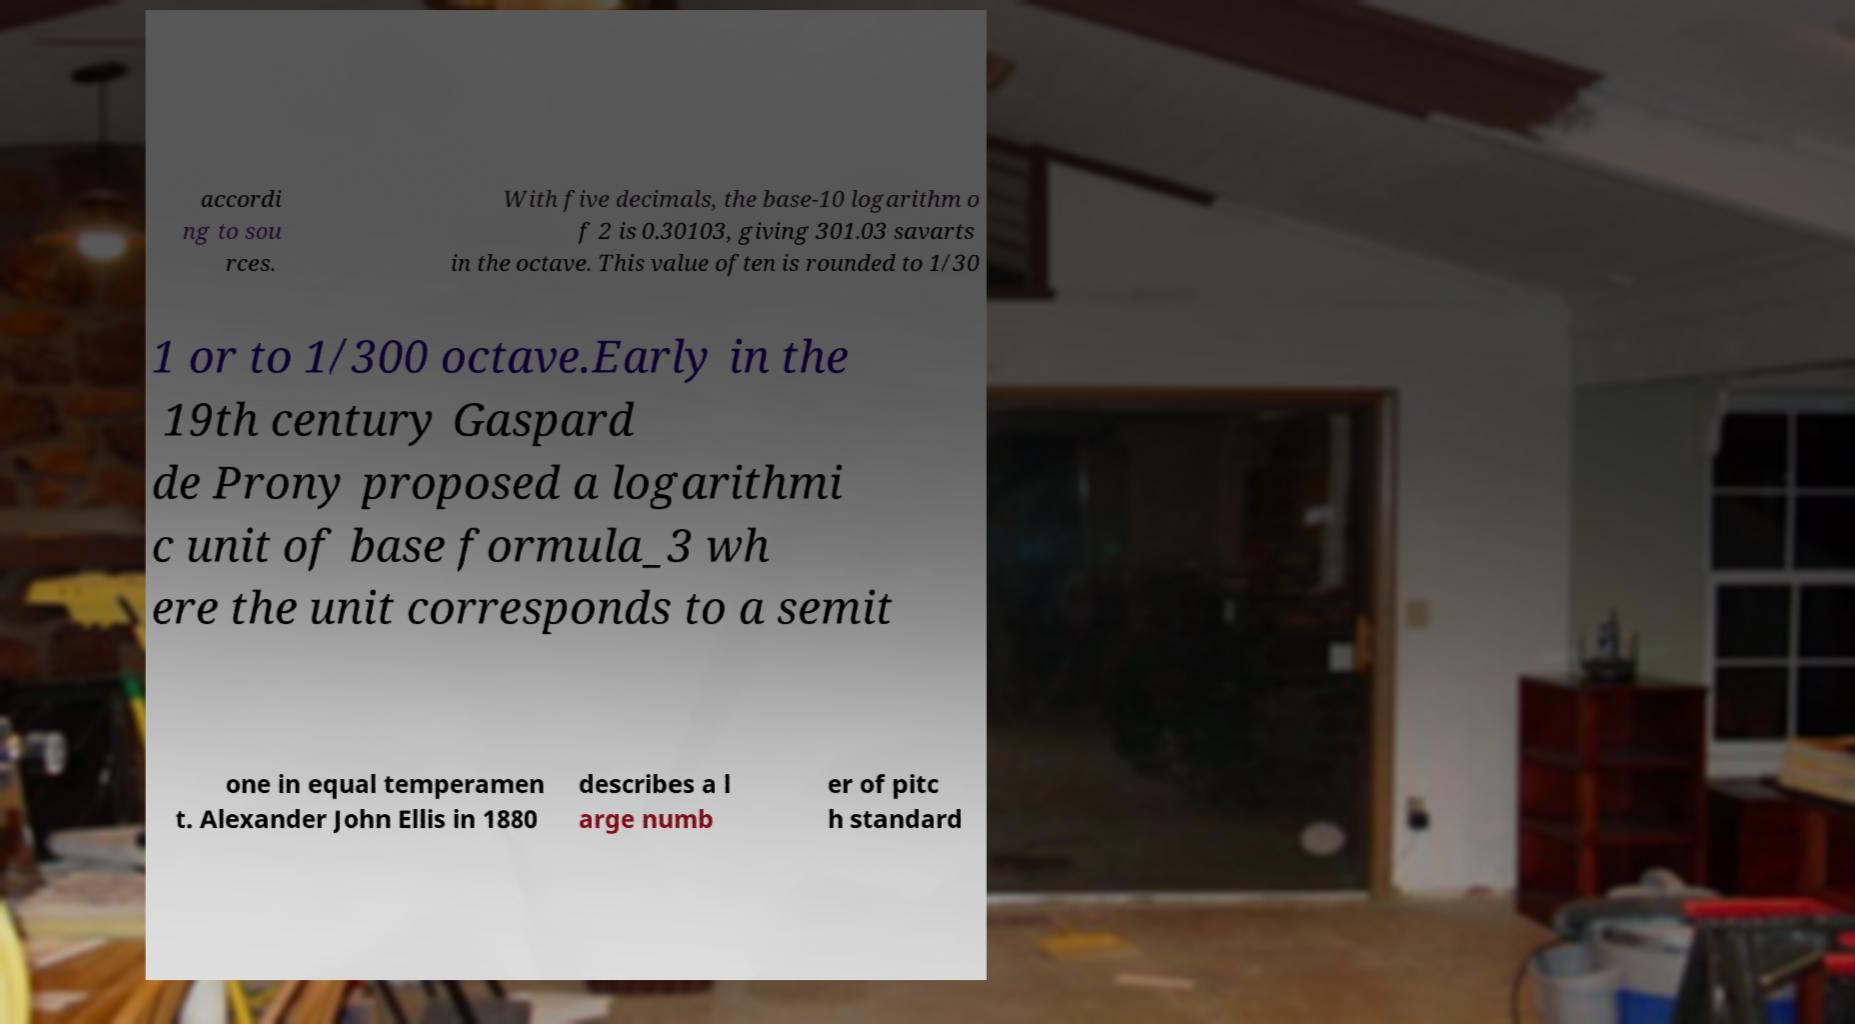Could you extract and type out the text from this image? accordi ng to sou rces. With five decimals, the base-10 logarithm o f 2 is 0.30103, giving 301.03 savarts in the octave. This value often is rounded to 1/30 1 or to 1/300 octave.Early in the 19th century Gaspard de Prony proposed a logarithmi c unit of base formula_3 wh ere the unit corresponds to a semit one in equal temperamen t. Alexander John Ellis in 1880 describes a l arge numb er of pitc h standard 